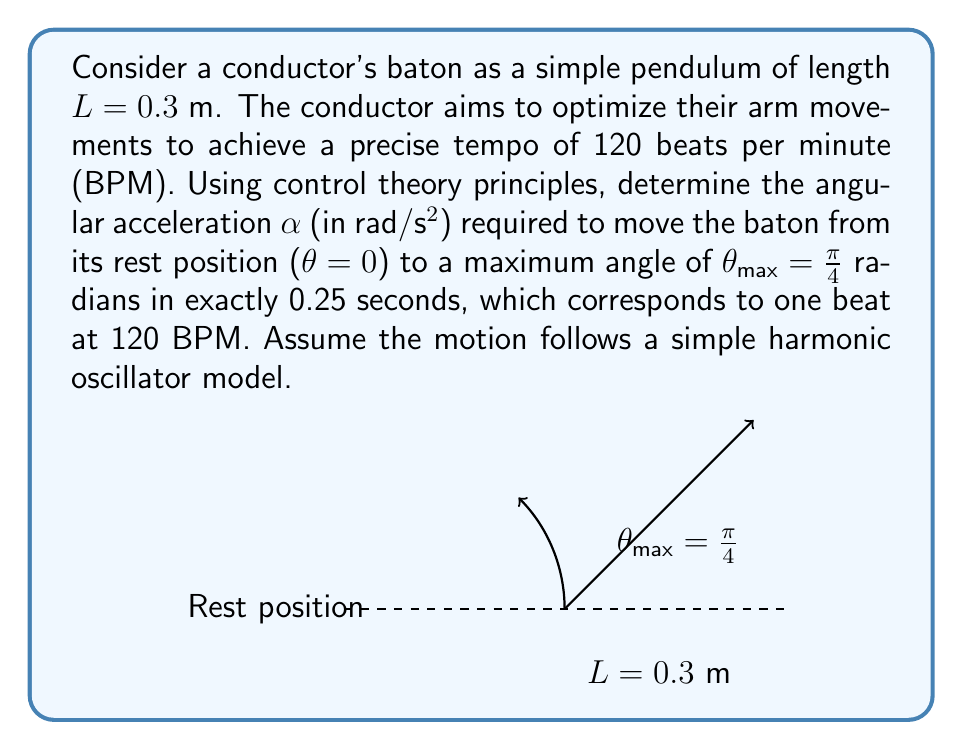Can you solve this math problem? To solve this problem, we'll use the equations of motion for a simple harmonic oscillator and apply control theory principles. Let's break it down step-by-step:

1) The equation of motion for a simple harmonic oscillator is:
   $$\theta(t) = \theta_{max} \cos(\omega t - \phi)$$
   where $\omega$ is the angular frequency and $\phi$ is the phase shift.

2) Given that the baton starts at rest ($\theta = 0$) and reaches $\theta_{max} = \frac{\pi}{4}$ at $t = 0.25$ s, we can determine $\omega$:
   $$\frac{\pi}{4} = \frac{\pi}{4} \cos(\omega \cdot 0.25 - 0)$$
   $$\cos(\omega \cdot 0.25) = 1$$
   $$\omega \cdot 0.25 = 2\pi$$
   $$\omega = 8\pi \text{ rad/s}$$

3) The angular velocity $\omega(t)$ is the derivative of $\theta(t)$:
   $$\omega(t) = -\theta_{max} \omega \sin(\omega t)$$

4) The angular acceleration $\alpha(t)$ is the derivative of $\omega(t)$:
   $$\alpha(t) = -\theta_{max} \omega^2 \cos(\omega t)$$

5) We want the maximum angular acceleration, which occurs at $t = 0$:
   $$\alpha_{max} = -\frac{\pi}{4} \cdot (8\pi)^2 \cdot \cos(0)$$
   $$\alpha_{max} = -\frac{\pi}{4} \cdot 64\pi^2$$
   $$\alpha_{max} = -16\pi^3 \text{ rad/s²}$$

6) The absolute value of this acceleration is the required angular acceleration:
   $$\alpha = 16\pi^3 \approx 493.48 \text{ rad/s²}$$

This angular acceleration will allow the conductor to move the baton precisely to achieve the desired tempo of 120 BPM.
Answer: $16\pi^3 \text{ rad/s²}$ 